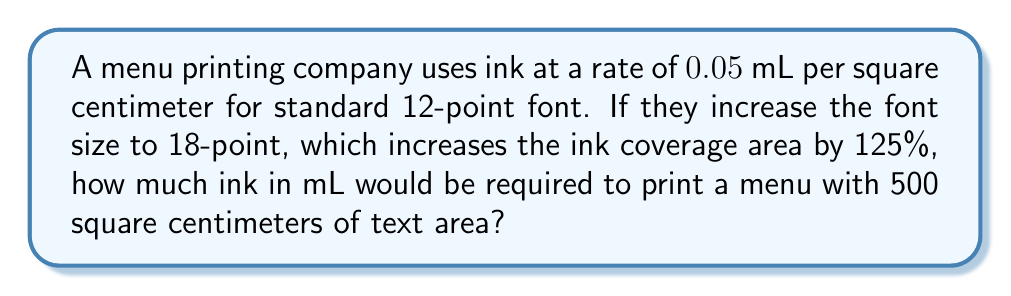Help me with this question. Let's approach this step-by-step:

1) First, we need to calculate the ink usage for standard 12-point font:
   $$ \text{Ink usage (12-point)} = 500 \text{ cm}^2 \times 0.05 \text{ mL/cm}^2 = 25 \text{ mL} $$

2) Now, we need to account for the increase in ink coverage area when switching to 18-point font:
   $$ \text{Increase factor} = 1 + 125\% = 2.25 $$

3) The new ink usage can be calculated by multiplying the standard usage by the increase factor:
   $$ \text{Ink usage (18-point)} = 25 \text{ mL} \times 2.25 = 56.25 \text{ mL} $$

Therefore, printing the menu with 18-point font would require 56.25 mL of ink.
Answer: 56.25 mL 